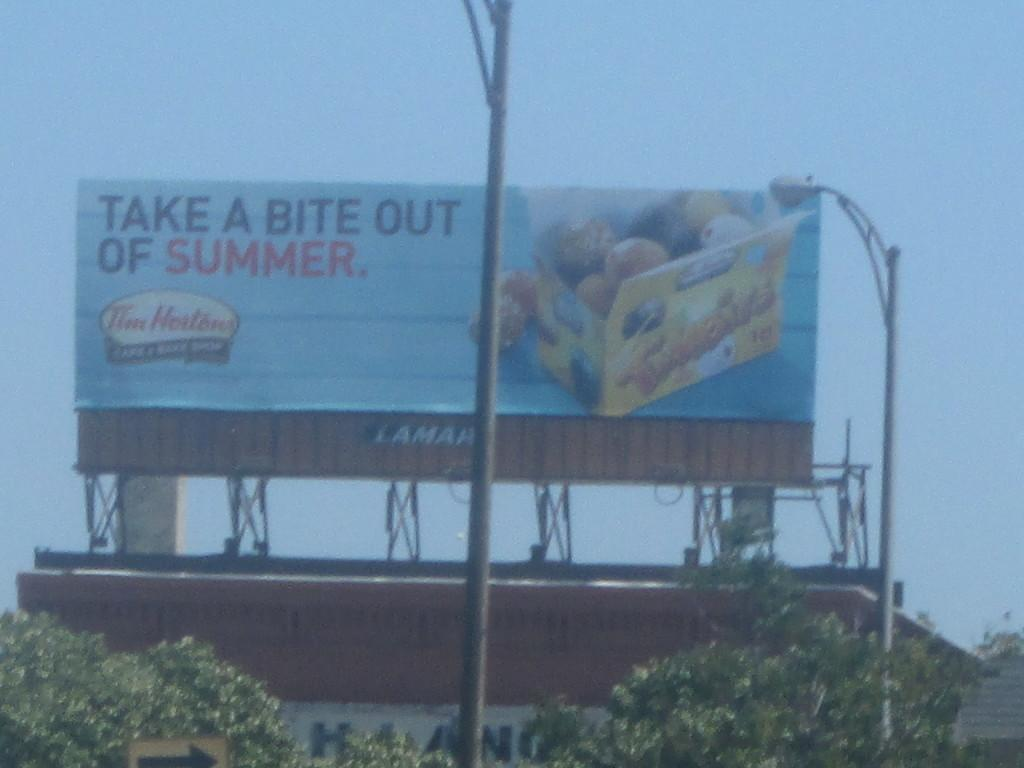<image>
Relay a brief, clear account of the picture shown. A billboard next to some street lights that reads TAKE A BITE OUT OF SUMMER. 